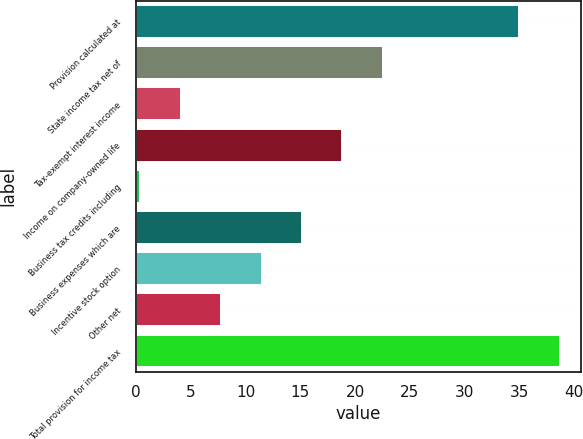Convert chart. <chart><loc_0><loc_0><loc_500><loc_500><bar_chart><fcel>Provision calculated at<fcel>State income tax net of<fcel>Tax-exempt interest income<fcel>Income on company-owned life<fcel>Business tax credits including<fcel>Business expenses which are<fcel>Incentive stock option<fcel>Other net<fcel>Total provision for income tax<nl><fcel>35<fcel>22.54<fcel>4.09<fcel>18.85<fcel>0.4<fcel>15.16<fcel>11.47<fcel>7.78<fcel>38.69<nl></chart> 